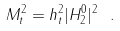<formula> <loc_0><loc_0><loc_500><loc_500>M _ { t } ^ { 2 } = h _ { t } ^ { 2 } | H _ { 2 } ^ { 0 } | ^ { 2 } \ .</formula> 